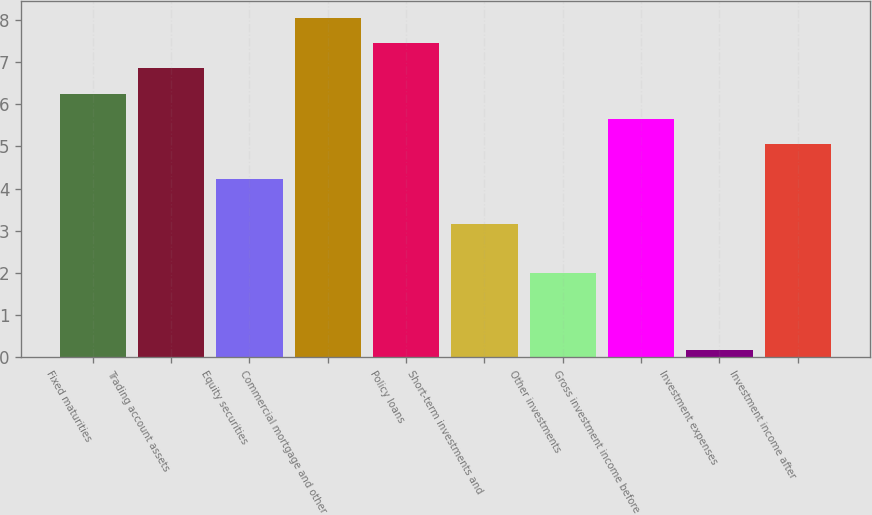<chart> <loc_0><loc_0><loc_500><loc_500><bar_chart><fcel>Fixed maturities<fcel>Trading account assets<fcel>Equity securities<fcel>Commercial mortgage and other<fcel>Policy loans<fcel>Short-term investments and<fcel>Other investments<fcel>Gross investment income before<fcel>Investment expenses<fcel>Investment income after<nl><fcel>6.25<fcel>6.85<fcel>4.24<fcel>8.05<fcel>7.45<fcel>3.17<fcel>2.01<fcel>5.65<fcel>0.17<fcel>5.05<nl></chart> 